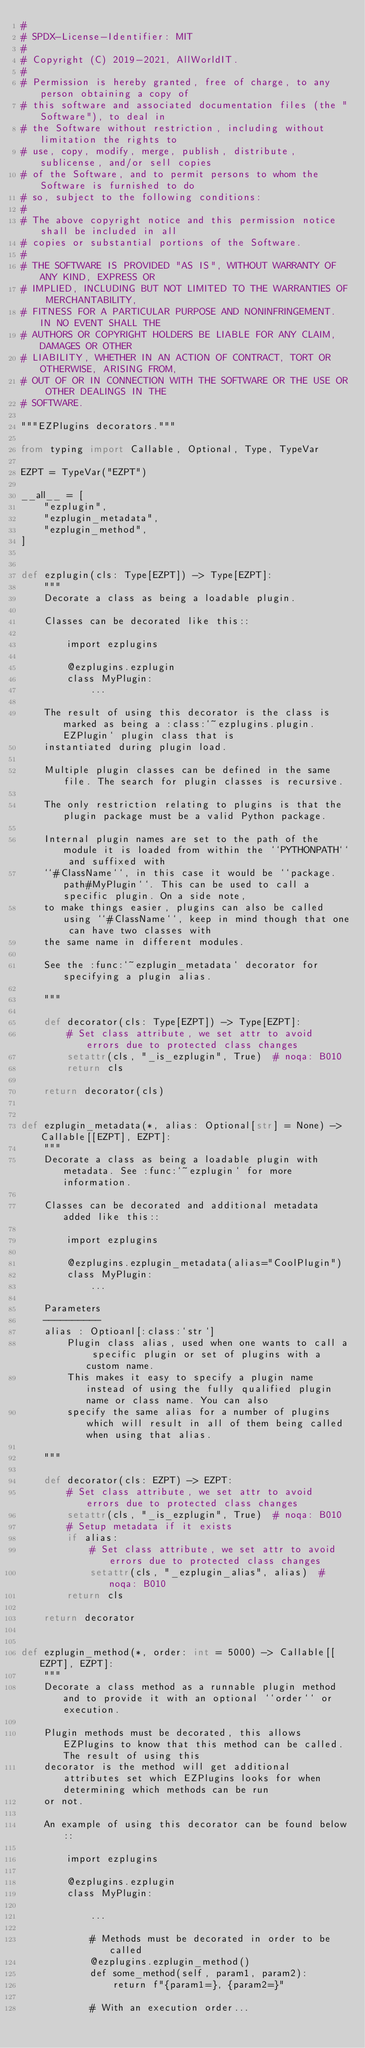<code> <loc_0><loc_0><loc_500><loc_500><_Python_>#
# SPDX-License-Identifier: MIT
#
# Copyright (C) 2019-2021, AllWorldIT.
#
# Permission is hereby granted, free of charge, to any person obtaining a copy of
# this software and associated documentation files (the "Software"), to deal in
# the Software without restriction, including without limitation the rights to
# use, copy, modify, merge, publish, distribute, sublicense, and/or sell copies
# of the Software, and to permit persons to whom the Software is furnished to do
# so, subject to the following conditions:
#
# The above copyright notice and this permission notice shall be included in all
# copies or substantial portions of the Software.
#
# THE SOFTWARE IS PROVIDED "AS IS", WITHOUT WARRANTY OF ANY KIND, EXPRESS OR
# IMPLIED, INCLUDING BUT NOT LIMITED TO THE WARRANTIES OF MERCHANTABILITY,
# FITNESS FOR A PARTICULAR PURPOSE AND NONINFRINGEMENT. IN NO EVENT SHALL THE
# AUTHORS OR COPYRIGHT HOLDERS BE LIABLE FOR ANY CLAIM, DAMAGES OR OTHER
# LIABILITY, WHETHER IN AN ACTION OF CONTRACT, TORT OR OTHERWISE, ARISING FROM,
# OUT OF OR IN CONNECTION WITH THE SOFTWARE OR THE USE OR OTHER DEALINGS IN THE
# SOFTWARE.

"""EZPlugins decorators."""

from typing import Callable, Optional, Type, TypeVar

EZPT = TypeVar("EZPT")

__all__ = [
    "ezplugin",
    "ezplugin_metadata",
    "ezplugin_method",
]


def ezplugin(cls: Type[EZPT]) -> Type[EZPT]:
    """
    Decorate a class as being a loadable plugin.

    Classes can be decorated like this::

        import ezplugins

        @ezplugins.ezplugin
        class MyPlugin:
            ...

    The result of using this decorator is the class is marked as being a :class:`~ezplugins.plugin.EZPlugin` plugin class that is
    instantiated during plugin load.

    Multiple plugin classes can be defined in the same file. The search for plugin classes is recursive.

    The only restriction relating to plugins is that the plugin package must be a valid Python package.

    Internal plugin names are set to the path of the module it is loaded from within the ``PYTHONPATH`` and suffixed with
    ``#ClassName``, in this case it would be ``package.path#MyPlugin``. This can be used to call a specific plugin. On a side note,
    to make things easier, plugins can also be called using ``#ClassName``, keep in mind though that one can have two classes with
    the same name in different modules.

    See the :func:`~ezplugin_metadata` decorator for specifying a plugin alias.

    """

    def decorator(cls: Type[EZPT]) -> Type[EZPT]:
        # Set class attribute, we set attr to avoid errors due to protected class changes
        setattr(cls, "_is_ezplugin", True)  # noqa: B010
        return cls

    return decorator(cls)


def ezplugin_metadata(*, alias: Optional[str] = None) -> Callable[[EZPT], EZPT]:
    """
    Decorate a class as being a loadable plugin with metadata. See :func:`~ezplugin` for more information.

    Classes can be decorated and additional metadata added like this::

        import ezplugins

        @ezplugins.ezplugin_metadata(alias="CoolPlugin")
        class MyPlugin:
            ...

    Parameters
    ----------
    alias : Optioanl[:class:`str`]
        Plugin class alias, used when one wants to call a specific plugin or set of plugins with a custom name.
        This makes it easy to specify a plugin name instead of using the fully qualified plugin name or class name. You can also
        specify the same alias for a number of plugins which will result in all of them being called when using that alias.

    """

    def decorator(cls: EZPT) -> EZPT:
        # Set class attribute, we set attr to avoid errors due to protected class changes
        setattr(cls, "_is_ezplugin", True)  # noqa: B010
        # Setup metadata if it exists
        if alias:
            # Set class attribute, we set attr to avoid errors due to protected class changes
            setattr(cls, "_ezplugin_alias", alias)  # noqa: B010
        return cls

    return decorator


def ezplugin_method(*, order: int = 5000) -> Callable[[EZPT], EZPT]:
    """
    Decorate a class method as a runnable plugin method and to provide it with an optional ``order`` or execution.

    Plugin methods must be decorated, this allows EZPlugins to know that this method can be called. The result of using this
    decorator is the method will get additional attributes set which EZPlugins looks for when determining which methods can be run
    or not.

    An example of using this decorator can be found below::

        import ezplugins

        @ezplugins.ezplugin
        class MyPlugin:

            ...

            # Methods must be decorated in order to be called
            @ezplugins.ezplugin_method()
            def some_method(self, param1, param2):
                return f"{param1=}, {param2=}"

            # With an execution order...</code> 